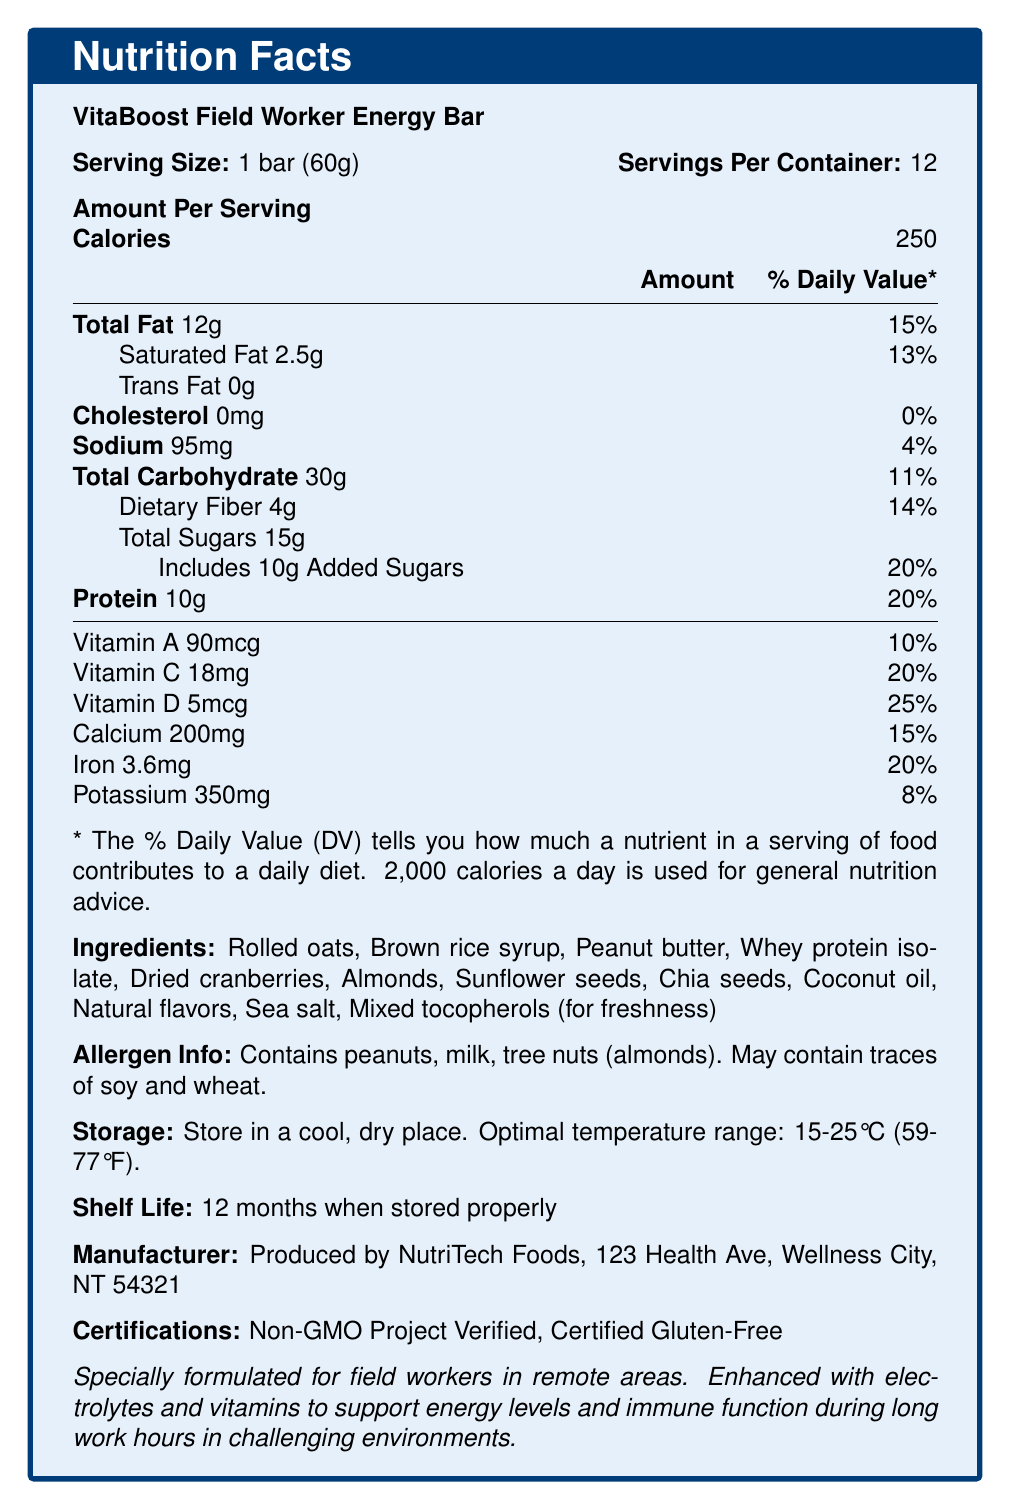what is the serving size of the VitaBoost Field Worker Energy Bar? The serving size is specified as "1 bar (60g)" in the document.
Answer: 1 bar (60g) how many calories are in one serving? The document lists the calories per serving as 250.
Answer: 250 calories how many servings are in one container? The document specifies that there are 12 servings per container.
Answer: 12 what is the total fat content per serving? According to the document, the total fat content per serving is 12g.
Answer: 12g what are the main ingredients listed in the VitaBoost Field Worker Energy Bar? These ingredients are listed under the "Ingredients" section of the document.
Answer: Rolled oats, Brown rice syrup, Peanut butter, Whey protein isolate, Dried cranberries, Almonds, Sunflower seeds, Chia seeds, Coconut oil, Natural flavors, Sea salt, Mixed tocopherols (for freshness) what percentage of the Daily Value is the added sugars content? A. 10% B. 20% C. 25% The document states that the added sugars amount to 20% of the Daily Value.
Answer: B. 20% which vitamin has the highest daily value percentage in the energy bar? A. Vitamin A B. Vitamin C C. Vitamin D The document indicates that Vitamin D has a daily value percentage of 25%, which is the highest among the listed vitamins.
Answer: C. Vitamin D is the energy bar gluten-free? One of the certifications listed in the document is "Certified Gluten-Free".
Answer: Yes what are the recommended storage conditions for the energy bar? The document provides specific storage instructions, including the optimal temperature range.
Answer: Store in a cool, dry place. Optimal temperature range: 15-25°C (59-77°F). how long is the shelf life of the energy bar? The document specifies that the shelf life of the energy bar is 12 months when stored properly.
Answer: 12 months is there any cholesterol in the energy bar? The document indicates that the cholesterol content is 0mg, which means there is no cholesterol in the energy bar.
Answer: No what is the name of the manufacturer? The manufacturer is listed as "NutriTech Foods" under the "Manufacturer" section.
Answer: NutriTech Foods does the energy bar contain any allergens? The document states that the bar contains peanuts, milk, and tree nuts (almonds), and may contain traces of soy and wheat.
Answer: Yes summarize the purpose and benefits of the VitaBoost Field Worker Energy Bar. The document highlights that the energy bar is enhanced with electrolytes and vitamins to support energy levels and immune function, making it suitable for field workers in tough conditions.
Answer: The VitaBoost Field Worker Energy Bar is specially formulated for field workers in remote areas, providing necessary nutrients, vitamins, and electrolytes to support energy levels and immune function during long work hours in challenging environments. what is the total carbohydrate content per serving? The document lists the total carbohydrate content per serving as 30g.
Answer: 30g how much protein is in one serving of the energy bar? The document states that each serving contains 10g of protein.
Answer: 10g what vitamins and minerals are included in the energy bar? The document provides details on the inclusion of these vitamins and minerals along with their amounts and daily value percentages.
Answer: Vitamin A, Vitamin C, Vitamin D, Calcium, Iron, Potassium how is the freshness of the energy bar preserved? The document states that mixed tocopherols are used for freshness.
Answer: Using mixed tocopherols what is the sodium content per serving? The sodium content per serving is listed as 95mg in the document.
Answer: 95mg are there any artificial flavors or preservatives in the energy bar? The document lists "Natural flavors" and does not specify whether there are artificial flavors or preservatives, so we cannot conclusively determine this based on the given information.
Answer: Cannot be determined 